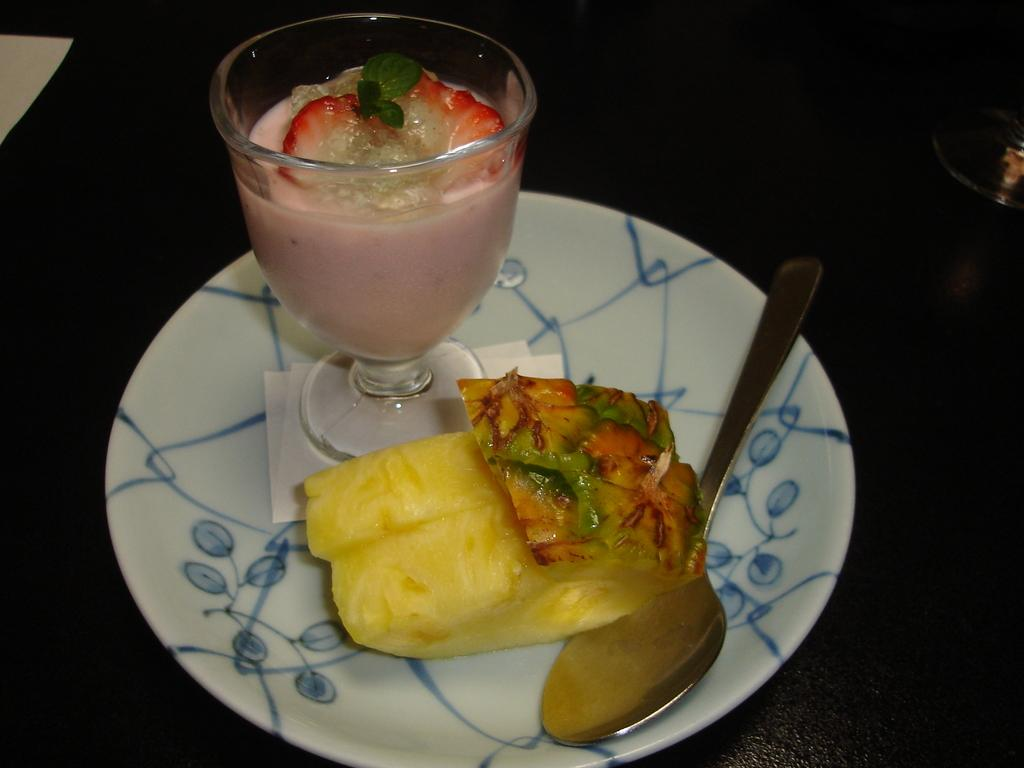What type of food items can be seen in the image? There are eatables in the image. Can you identify a specific type of eatable in the image? Yes, there is a shake in the image. What utensil is present in the image? There is a spoon in the image. Where is the spoon placed? The spoon is placed on a white plate. Is there a loaf of bread being used to stir the shake in the image? No, there is no loaf of bread present in the image, and the shake is not being stirred. 